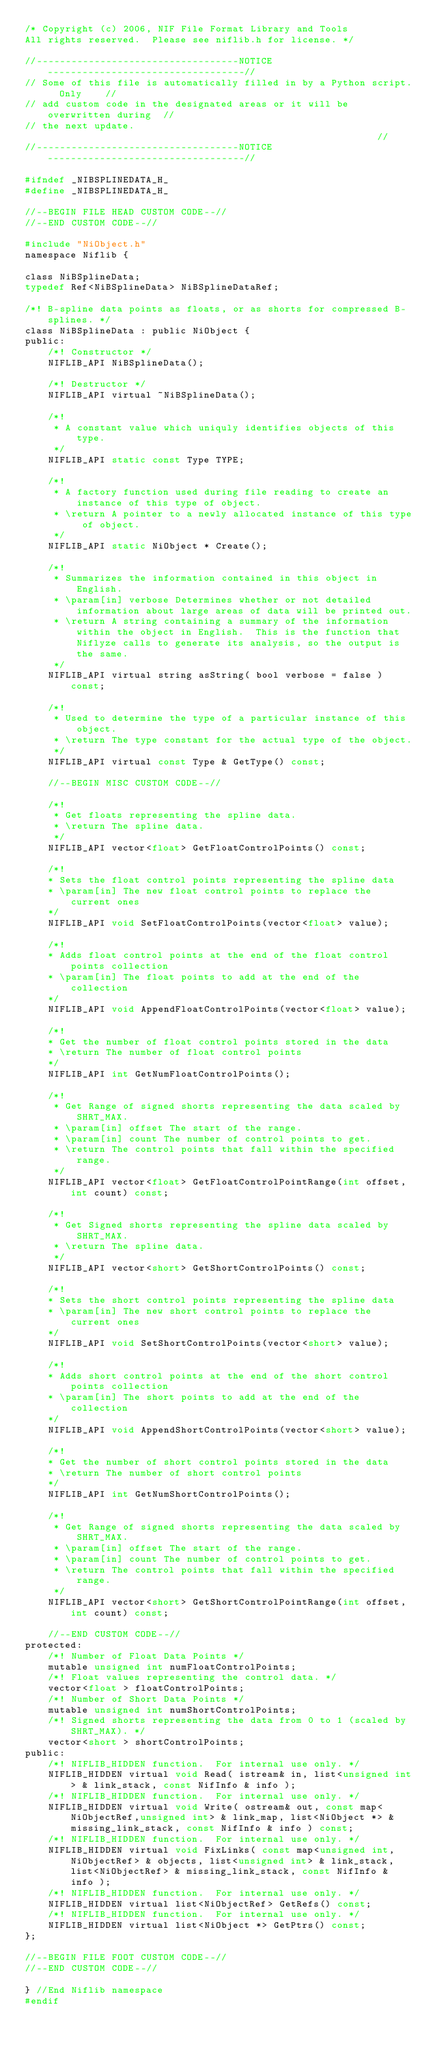Convert code to text. <code><loc_0><loc_0><loc_500><loc_500><_C_>/* Copyright (c) 2006, NIF File Format Library and Tools
All rights reserved.  Please see niflib.h for license. */

//-----------------------------------NOTICE----------------------------------//
// Some of this file is automatically filled in by a Python script.  Only    //
// add custom code in the designated areas or it will be overwritten during  //
// the next update.                                                          //
//-----------------------------------NOTICE----------------------------------//

#ifndef _NIBSPLINEDATA_H_
#define _NIBSPLINEDATA_H_

//--BEGIN FILE HEAD CUSTOM CODE--//
//--END CUSTOM CODE--//

#include "NiObject.h"
namespace Niflib {

class NiBSplineData;
typedef Ref<NiBSplineData> NiBSplineDataRef;

/*! B-spline data points as floats, or as shorts for compressed B-splines. */
class NiBSplineData : public NiObject {
public:
	/*! Constructor */
	NIFLIB_API NiBSplineData();

	/*! Destructor */
	NIFLIB_API virtual ~NiBSplineData();

	/*!
	 * A constant value which uniquly identifies objects of this type.
	 */
	NIFLIB_API static const Type TYPE;

	/*!
	 * A factory function used during file reading to create an instance of this type of object.
	 * \return A pointer to a newly allocated instance of this type of object.
	 */
	NIFLIB_API static NiObject * Create();

	/*!
	 * Summarizes the information contained in this object in English.
	 * \param[in] verbose Determines whether or not detailed information about large areas of data will be printed out.
	 * \return A string containing a summary of the information within the object in English.  This is the function that Niflyze calls to generate its analysis, so the output is the same.
	 */
	NIFLIB_API virtual string asString( bool verbose = false ) const;

	/*!
	 * Used to determine the type of a particular instance of this object.
	 * \return The type constant for the actual type of the object.
	 */
	NIFLIB_API virtual const Type & GetType() const;

	//--BEGIN MISC CUSTOM CODE--//

	/*!
	 * Get floats representing the spline data.
	 * \return The spline data.
	 */
	NIFLIB_API vector<float> GetFloatControlPoints() const;

	/*!
	* Sets the float control points representing the spline data
	* \param[in] The new float control points to replace the current ones
	*/
	NIFLIB_API void SetFloatControlPoints(vector<float> value);

	/*!
	* Adds float control points at the end of the float control points collection 
	* \param[in] The float points to add at the end of the collection
	*/
	NIFLIB_API void AppendFloatControlPoints(vector<float> value);

	/*!
	* Get the number of float control points stored in the data
	* \return The number of float control points
	*/
	NIFLIB_API int GetNumFloatControlPoints();

	/*!
	 * Get Range of signed shorts representing the data scaled by SHRT_MAX.
	 * \param[in] offset The start of the range.
	 * \param[in] count The number of control points to get.
	 * \return The control points that fall within the specified range.
	 */
	NIFLIB_API vector<float> GetFloatControlPointRange(int offset, int count) const;

	/*!
	 * Get Signed shorts representing the spline data scaled by SHRT_MAX.
	 * \return The spline data.
	 */
	NIFLIB_API vector<short> GetShortControlPoints() const;

	/*!
	* Sets the short control points representing the spline data
	* \param[in] The new short control points to replace the current ones
	*/
	NIFLIB_API void SetShortControlPoints(vector<short> value);

	/*!
	* Adds short control points at the end of the short control points collection 
	* \param[in] The short points to add at the end of the collection
	*/
	NIFLIB_API void AppendShortControlPoints(vector<short> value);

	/*!
	* Get the number of short control points stored in the data
	* \return The number of short control points
	*/
	NIFLIB_API int GetNumShortControlPoints();

	/*!
	 * Get Range of signed shorts representing the data scaled by SHRT_MAX.
	 * \param[in] offset The start of the range.
	 * \param[in] count The number of control points to get.
	 * \return The control points that fall within the specified range.
	 */
	NIFLIB_API vector<short> GetShortControlPointRange(int offset, int count) const;

	//--END CUSTOM CODE--//
protected:
	/*! Number of Float Data Points */
	mutable unsigned int numFloatControlPoints;
	/*! Float values representing the control data. */
	vector<float > floatControlPoints;
	/*! Number of Short Data Points */
	mutable unsigned int numShortControlPoints;
	/*! Signed shorts representing the data from 0 to 1 (scaled by SHRT_MAX). */
	vector<short > shortControlPoints;
public:
	/*! NIFLIB_HIDDEN function.  For internal use only. */
	NIFLIB_HIDDEN virtual void Read( istream& in, list<unsigned int> & link_stack, const NifInfo & info );
	/*! NIFLIB_HIDDEN function.  For internal use only. */
	NIFLIB_HIDDEN virtual void Write( ostream& out, const map<NiObjectRef,unsigned int> & link_map, list<NiObject *> & missing_link_stack, const NifInfo & info ) const;
	/*! NIFLIB_HIDDEN function.  For internal use only. */
	NIFLIB_HIDDEN virtual void FixLinks( const map<unsigned int,NiObjectRef> & objects, list<unsigned int> & link_stack, list<NiObjectRef> & missing_link_stack, const NifInfo & info );
	/*! NIFLIB_HIDDEN function.  For internal use only. */
	NIFLIB_HIDDEN virtual list<NiObjectRef> GetRefs() const;
	/*! NIFLIB_HIDDEN function.  For internal use only. */
	NIFLIB_HIDDEN virtual list<NiObject *> GetPtrs() const;
};

//--BEGIN FILE FOOT CUSTOM CODE--//
//--END CUSTOM CODE--//

} //End Niflib namespace
#endif
</code> 